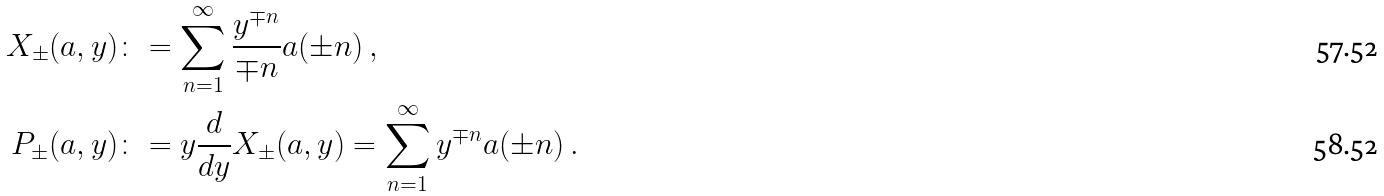Convert formula to latex. <formula><loc_0><loc_0><loc_500><loc_500>X _ { \pm } ( a , y ) & \colon = \sum _ { n = 1 } ^ { \infty } \frac { y ^ { \mp n } } { \mp n } a ( \pm n ) \, , \\ P _ { \pm } ( a , y ) & \colon = y \frac { d } { d y } X _ { \pm } ( a , y ) = \sum _ { n = 1 } ^ { \infty } y ^ { \mp n } a ( \pm n ) \, .</formula> 